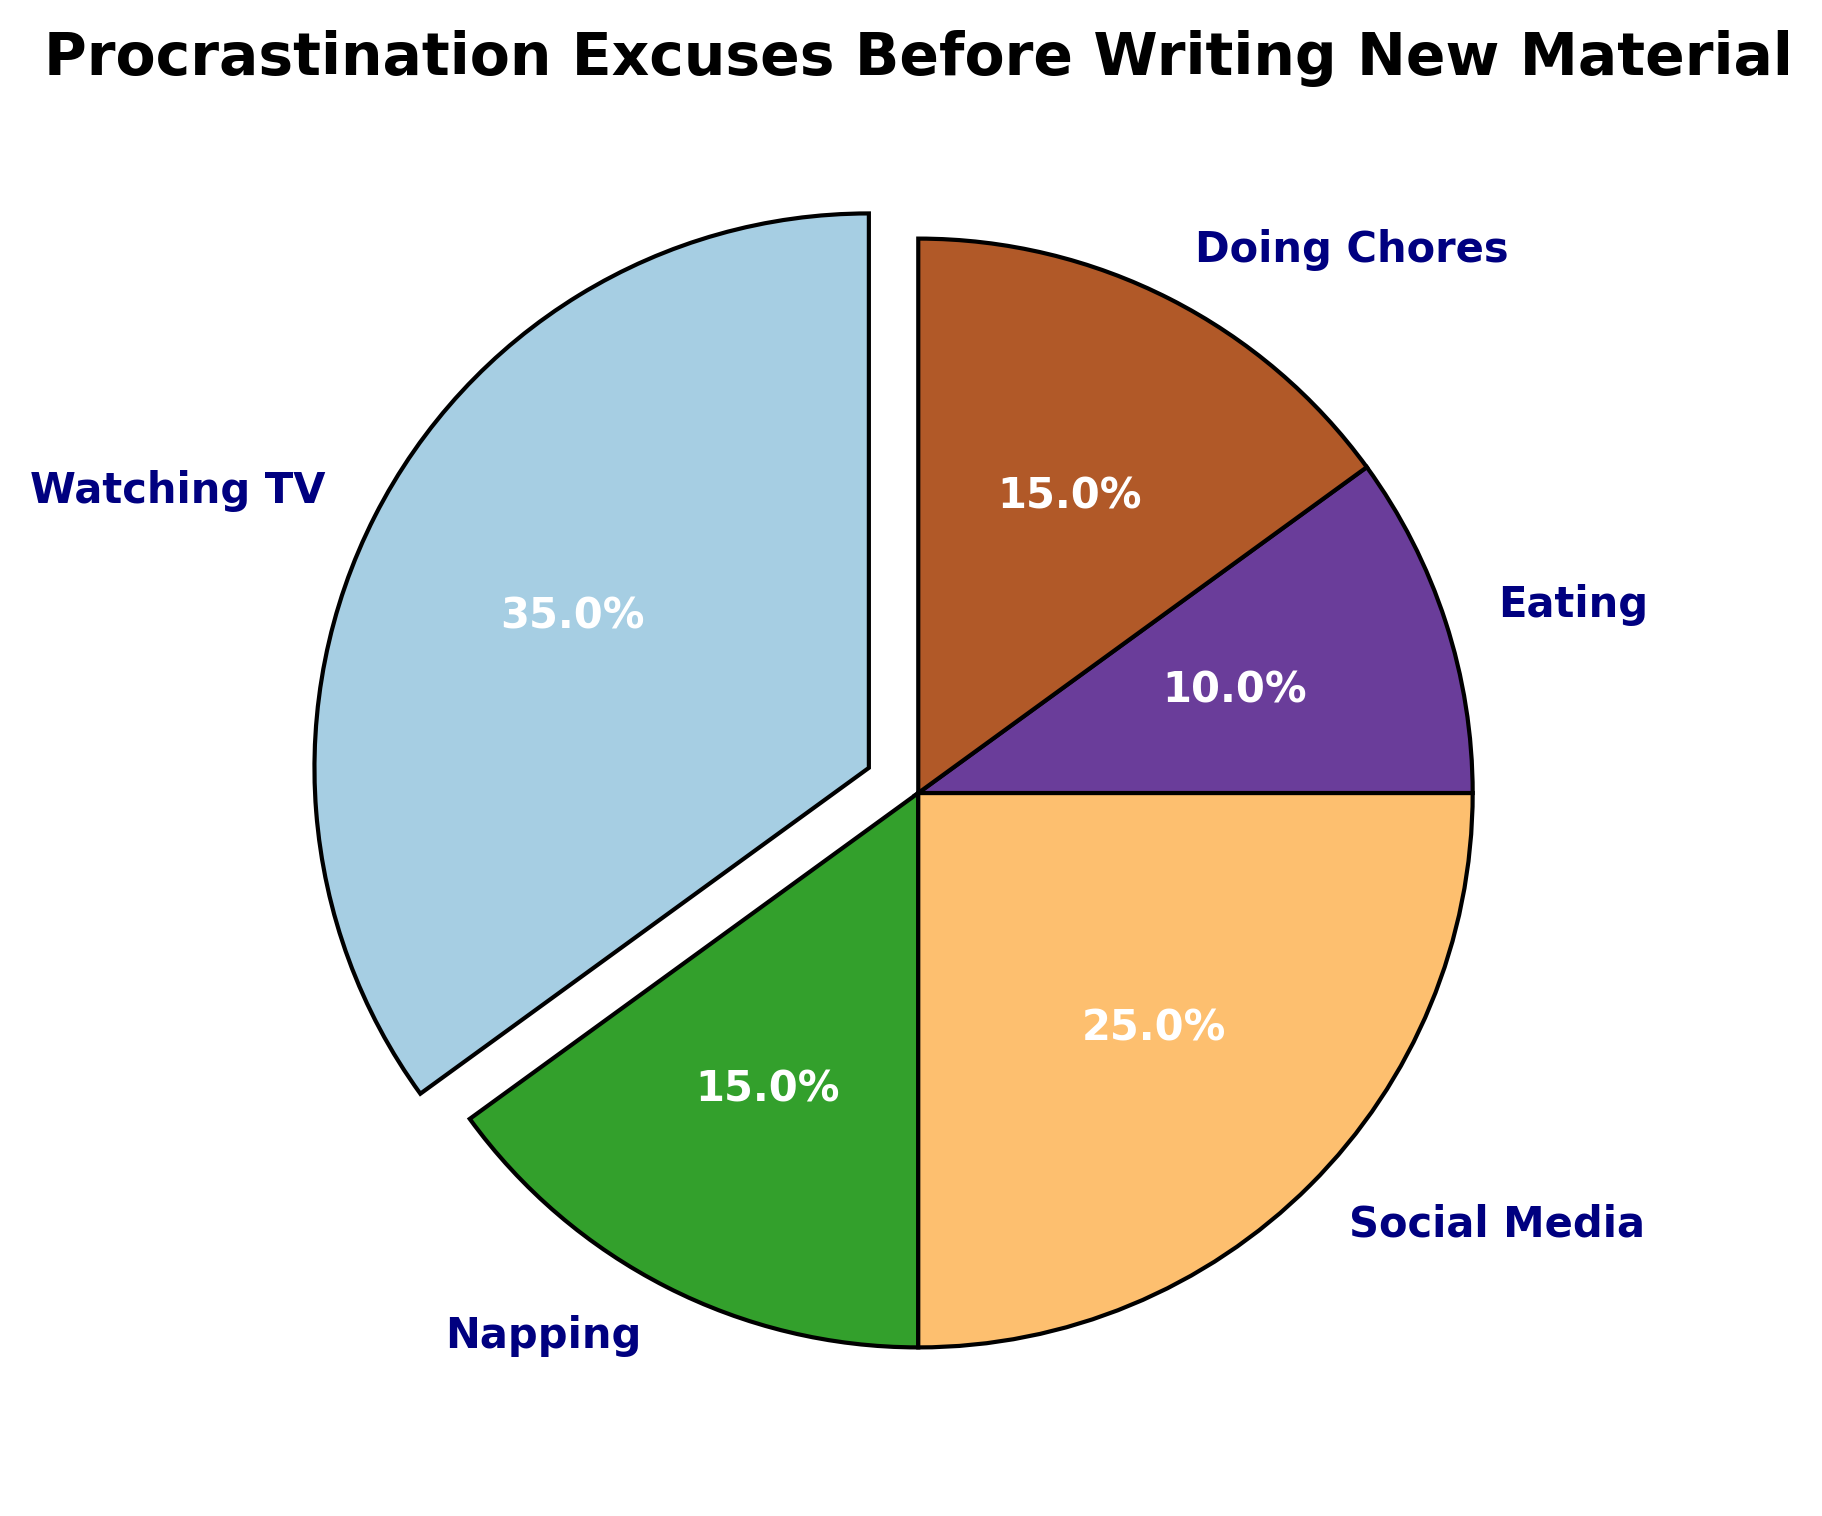Which activity is the most common procrastination excuse? The largest slice of the pie chart, which has an exploded section, represents Watching TV with 35% of the total.
Answer: Watching TV How much more percent do people spend on Social Media compared to Eating? Social Media occupies 25% of the pie chart while Eating occupies 10%. The difference is 25% - 10% = 15%.
Answer: 15% What's the total percentage of procrastination excuses for Napping and Doing Chores combined? Napping occupies 15% and Doing Chores also occupies 15%. Combined, the sum is 15% + 15% = 30%.
Answer: 30% Which two activities occupy the same percentage in the pie chart, and what is that percentage? Napping and Doing Chores both occupy the same size slice, which is 15% each.
Answer: Napping and Doing Chores, 15% What's the least common procrastination excuse according to the pie chart? The smallest slice of the pie chart belongs to Eating with 10%.
Answer: Eating Calculate the ratio of time spent on Watching TV to the total time spent on Napping and Eating. Watching TV occupies 35%, Napping takes 15%, and Eating takes 10%. The ratio is 35% to (15% + 10%) = 35% to 25%. Simplified, this ratio is 35:25 or 7:5.
Answer: 7:5 If procrastination time is equally divided among 4 people for Social Media, what percentage of total procrastination excuses does each person get? Social Media occupies 25% of the pie chart. Dividing 25% equally among 4 people: 25% / 4 = 6.25%.
Answer: 6.25% Which activity's slice is visually highlighted and why? The slice for Watching TV is highlighted as it is exploded outwards in the chart, making it visually distinct.
Answer: Watching TV, because it's exploded What percent of the total procrastination time is not spent on Social Media or Watching TV? Watching TV is 35%, Social Media is 25%. Total = 35% + 25% = 60%. The remaining percentage is 100% - 60% = 40%.
Answer: 40% Compare the total procrastination time spent on Eating, Napping, and Doing Chores. Is it more or less than the time spent on Watching TV? Eating is 10%, Napping is 15%, and Doing Chores is 15%. Combined = 10% + 15% + 15% = 40%. Watching TV is 35%. Therefore, the time spent on Eating, Napping, and Doing Chores (40%) is more than Watching TV (35%).
Answer: More 